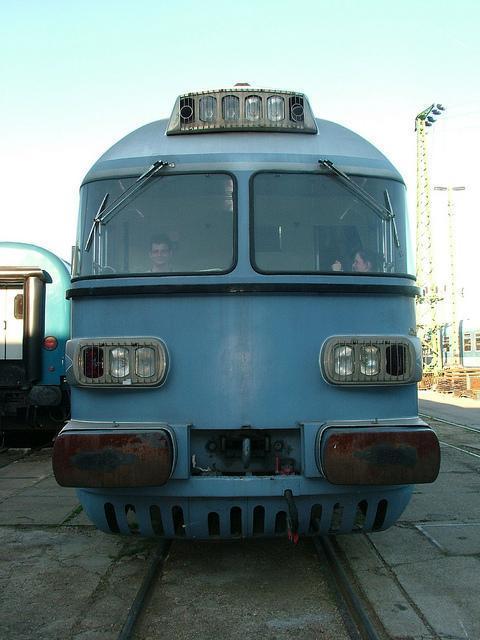How many windshield wipers does this train have?
Give a very brief answer. 2. How many trains are there?
Give a very brief answer. 2. How many people are wearing an orange shirt?
Give a very brief answer. 0. 